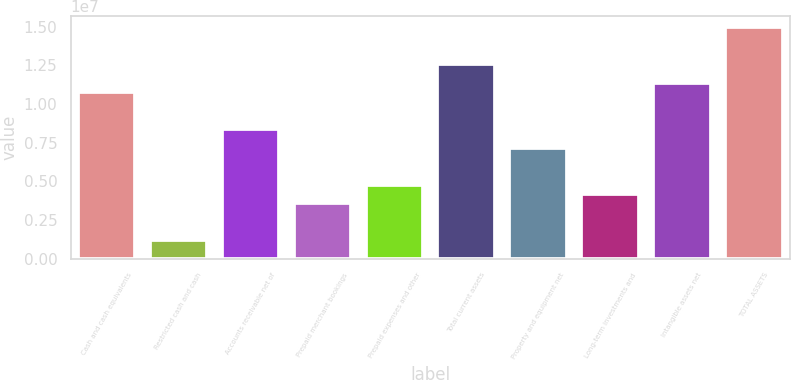Convert chart. <chart><loc_0><loc_0><loc_500><loc_500><bar_chart><fcel>Cash and cash equivalents<fcel>Restricted cash and cash<fcel>Accounts receivable net of<fcel>Prepaid merchant bookings<fcel>Prepaid expenses and other<fcel>Total current assets<fcel>Property and equipment net<fcel>Long-term investments and<fcel>Intangible assets net<fcel>TOTAL ASSETS<nl><fcel>1.07631e+07<fcel>1.19592e+06<fcel>8.37127e+06<fcel>3.5877e+06<fcel>4.78359e+06<fcel>1.25569e+07<fcel>7.17538e+06<fcel>4.18565e+06<fcel>1.1361e+07<fcel>1.49487e+07<nl></chart> 